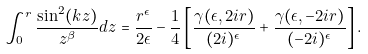<formula> <loc_0><loc_0><loc_500><loc_500>\int _ { 0 } ^ { r } \frac { \sin ^ { 2 } ( k z ) } { z ^ { \beta } } d z = \frac { r ^ { \epsilon } } { 2 \epsilon } - \frac { 1 } { 4 } \left [ \frac { \gamma ( \epsilon , 2 i r ) } { ( 2 i ) ^ { \epsilon } } + \frac { \gamma ( \epsilon , - 2 i r ) } { ( - 2 i ) ^ { \epsilon } } \right ] .</formula> 